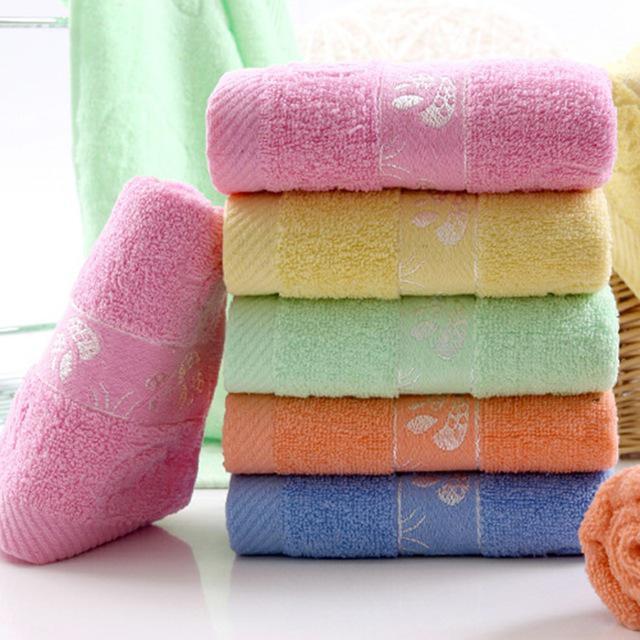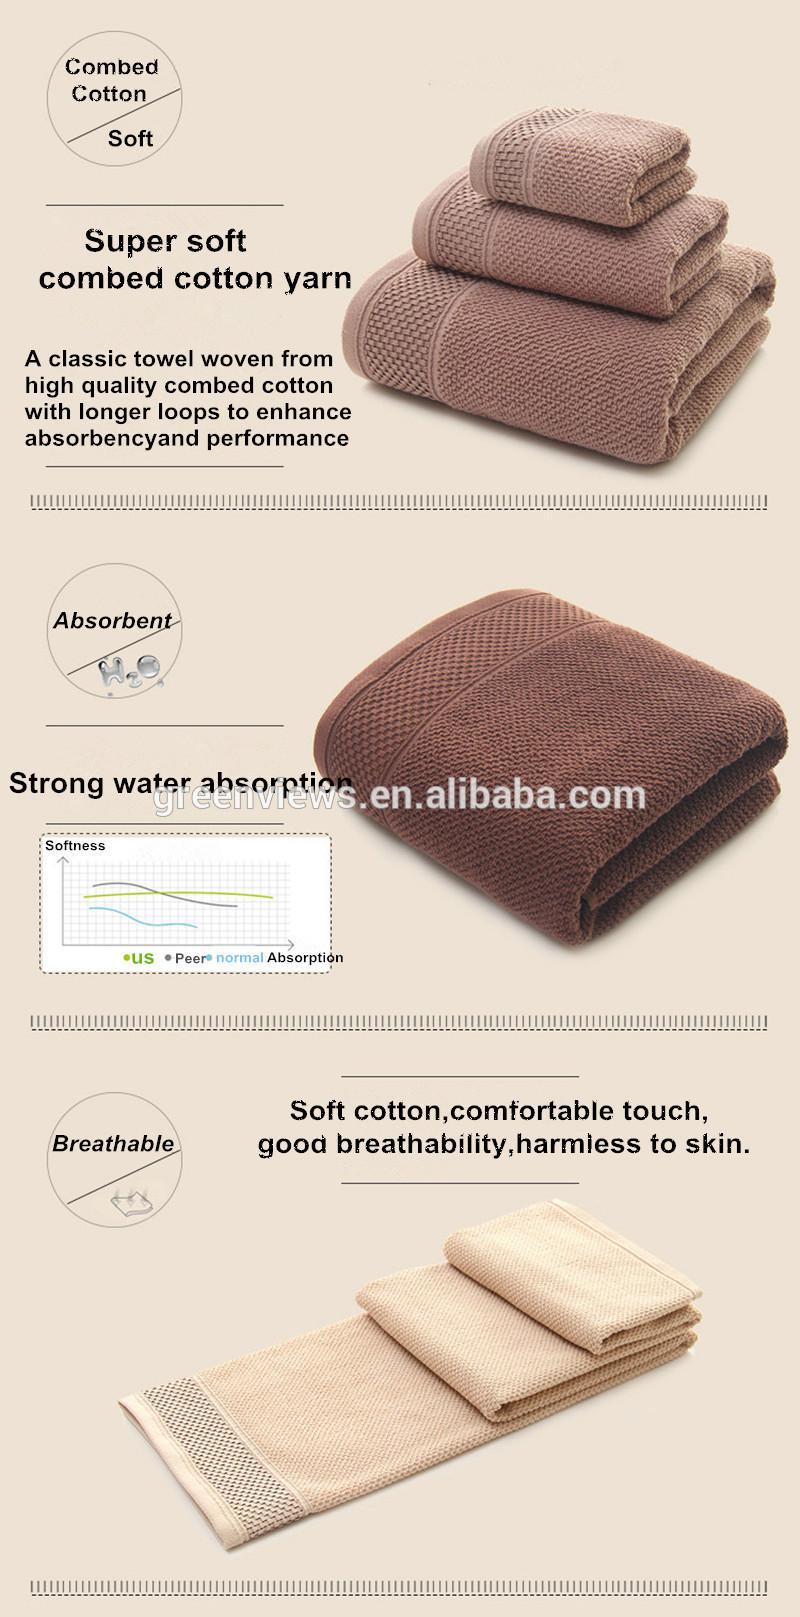The first image is the image on the left, the second image is the image on the right. For the images displayed, is the sentence "There are exactly three folded towels in at least one image." factually correct? Answer yes or no. No. The first image is the image on the left, the second image is the image on the right. For the images shown, is this caption "There is exactly one yellow towel." true? Answer yes or no. Yes. 